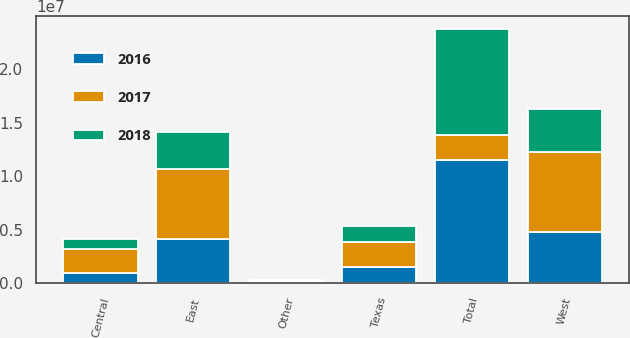Convert chart. <chart><loc_0><loc_0><loc_500><loc_500><stacked_bar_chart><ecel><fcel>East<fcel>Central<fcel>Texas<fcel>West<fcel>Other<fcel>Total<nl><fcel>2017<fcel>6.50587e+06<fcel>2.26395e+06<fcel>2.28473e+06<fcel>7.54424e+06<fcel>82522<fcel>2.28473e+06<nl><fcel>2016<fcel>4.19065e+06<fcel>968771<fcel>1.54042e+06<fcel>4.75266e+06<fcel>106741<fcel>1.15592e+07<nl><fcel>2018<fcel>3.41786e+06<fcel>867632<fcel>1.56251e+06<fcel>4.02572e+06<fcel>80214<fcel>9.95394e+06<nl></chart> 